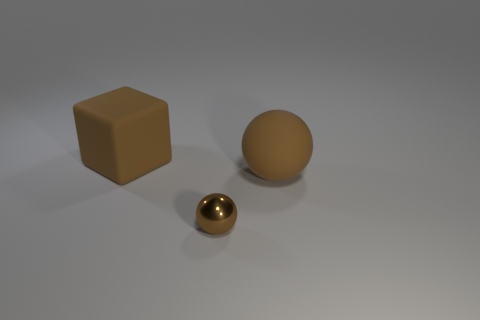Add 3 large spheres. How many objects exist? 6 Subtract all balls. How many objects are left? 1 Add 2 small objects. How many small objects exist? 3 Subtract 0 cyan cylinders. How many objects are left? 3 Subtract all big things. Subtract all metal blocks. How many objects are left? 1 Add 2 large blocks. How many large blocks are left? 3 